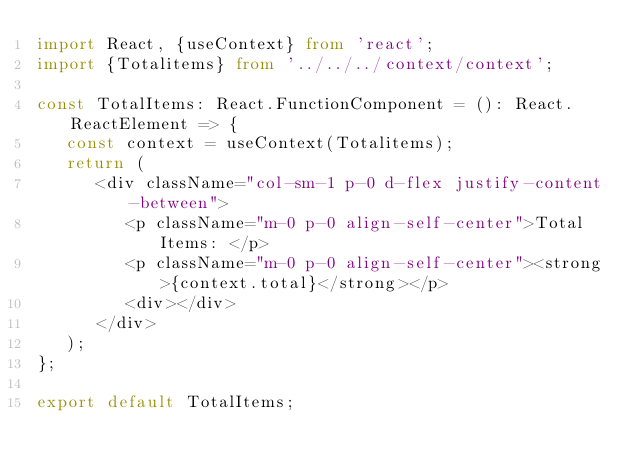Convert code to text. <code><loc_0><loc_0><loc_500><loc_500><_TypeScript_>import React, {useContext} from 'react';
import {Totalitems} from '../../../context/context';

const TotalItems: React.FunctionComponent = (): React.ReactElement => {
   const context = useContext(Totalitems);
   return (
      <div className="col-sm-1 p-0 d-flex justify-content-between">
         <p className="m-0 p-0 align-self-center">Total Items: </p>
         <p className="m-0 p-0 align-self-center"><strong>{context.total}</strong></p>
         <div></div>
      </div>
   );
};

export default TotalItems;</code> 